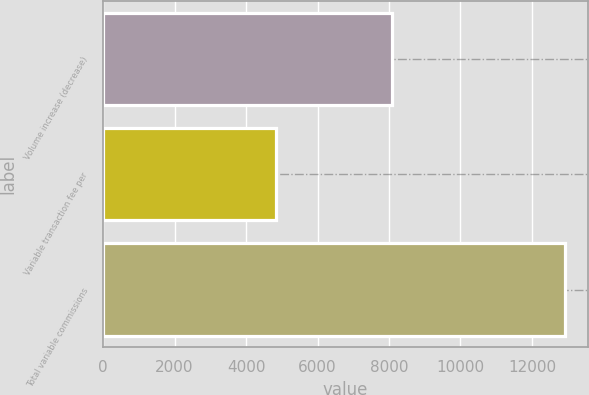Convert chart to OTSL. <chart><loc_0><loc_0><loc_500><loc_500><bar_chart><fcel>Volume increase (decrease)<fcel>Variable transaction fee per<fcel>Total variable commissions<nl><fcel>8095<fcel>4826<fcel>12921<nl></chart> 